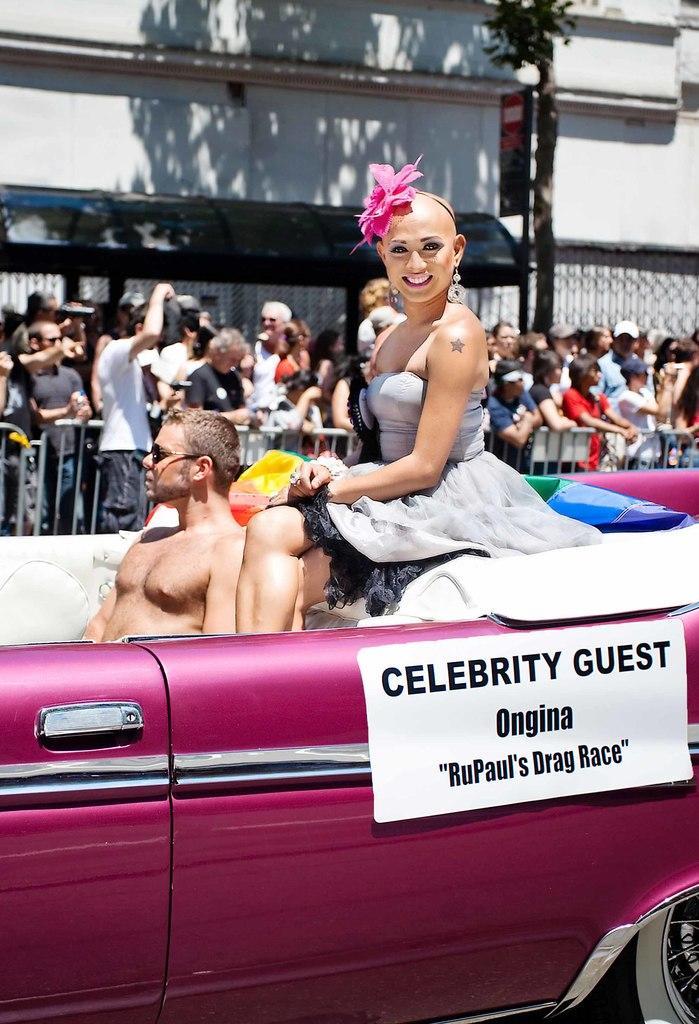How would you summarize this image in a sentence or two? This picture is taken outside. There are two persons sitting in the car, one man and one woman. Woman is wearing a grey dress and a flower crown. In the background there are group of people and a wall. 